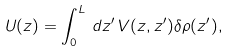<formula> <loc_0><loc_0><loc_500><loc_500>U ( z ) = \int _ { 0 } ^ { L } \, d z ^ { \prime } \, V ( z , z ^ { \prime } ) \delta \rho ( z ^ { \prime } ) ,</formula> 